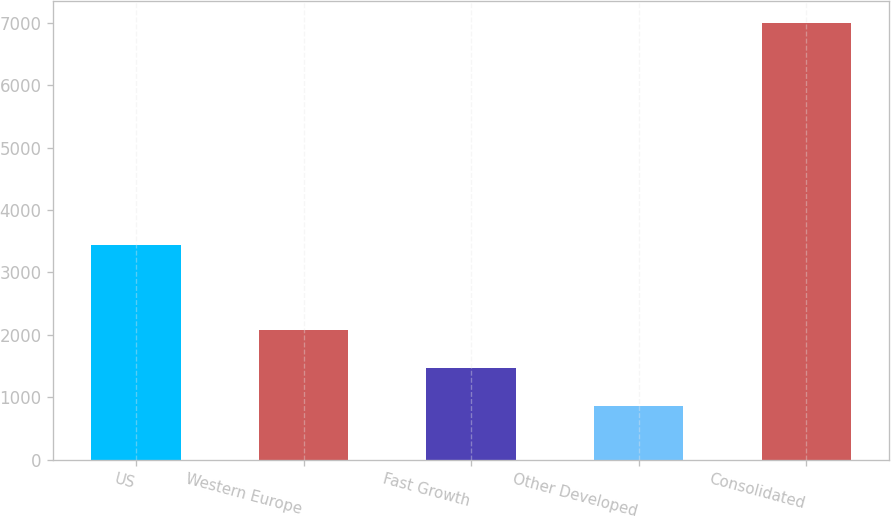<chart> <loc_0><loc_0><loc_500><loc_500><bar_chart><fcel>US<fcel>Western Europe<fcel>Fast Growth<fcel>Other Developed<fcel>Consolidated<nl><fcel>3431.3<fcel>2081.14<fcel>1466.32<fcel>851.5<fcel>6999.7<nl></chart> 